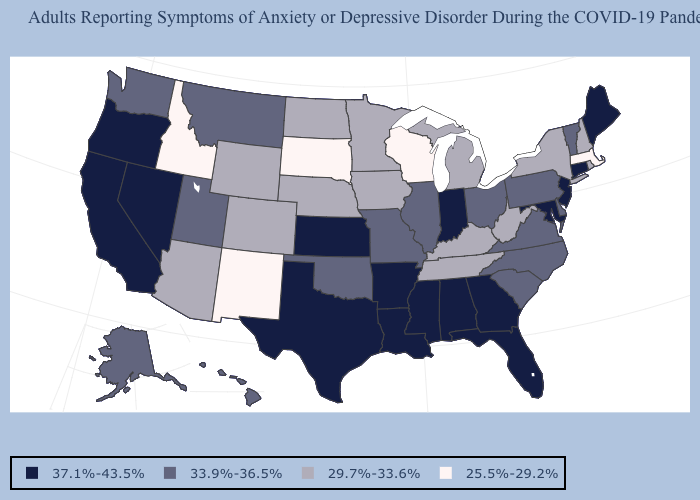Among the states that border New Jersey , which have the highest value?
Be succinct. Delaware, Pennsylvania. Does California have the highest value in the West?
Quick response, please. Yes. What is the lowest value in the USA?
Be succinct. 25.5%-29.2%. Does the map have missing data?
Keep it brief. No. Does Texas have the highest value in the South?
Be succinct. Yes. Among the states that border Ohio , does Indiana have the highest value?
Give a very brief answer. Yes. What is the value of Arizona?
Quick response, please. 29.7%-33.6%. What is the value of Maine?
Keep it brief. 37.1%-43.5%. Name the states that have a value in the range 33.9%-36.5%?
Be succinct. Alaska, Delaware, Hawaii, Illinois, Missouri, Montana, North Carolina, Ohio, Oklahoma, Pennsylvania, South Carolina, Utah, Vermont, Virginia, Washington. Does New Jersey have a higher value than North Dakota?
Short answer required. Yes. What is the value of Pennsylvania?
Be succinct. 33.9%-36.5%. What is the value of Maryland?
Write a very short answer. 37.1%-43.5%. What is the value of California?
Concise answer only. 37.1%-43.5%. Name the states that have a value in the range 25.5%-29.2%?
Give a very brief answer. Idaho, Massachusetts, New Mexico, South Dakota, Wisconsin. Among the states that border Montana , does North Dakota have the highest value?
Short answer required. Yes. 